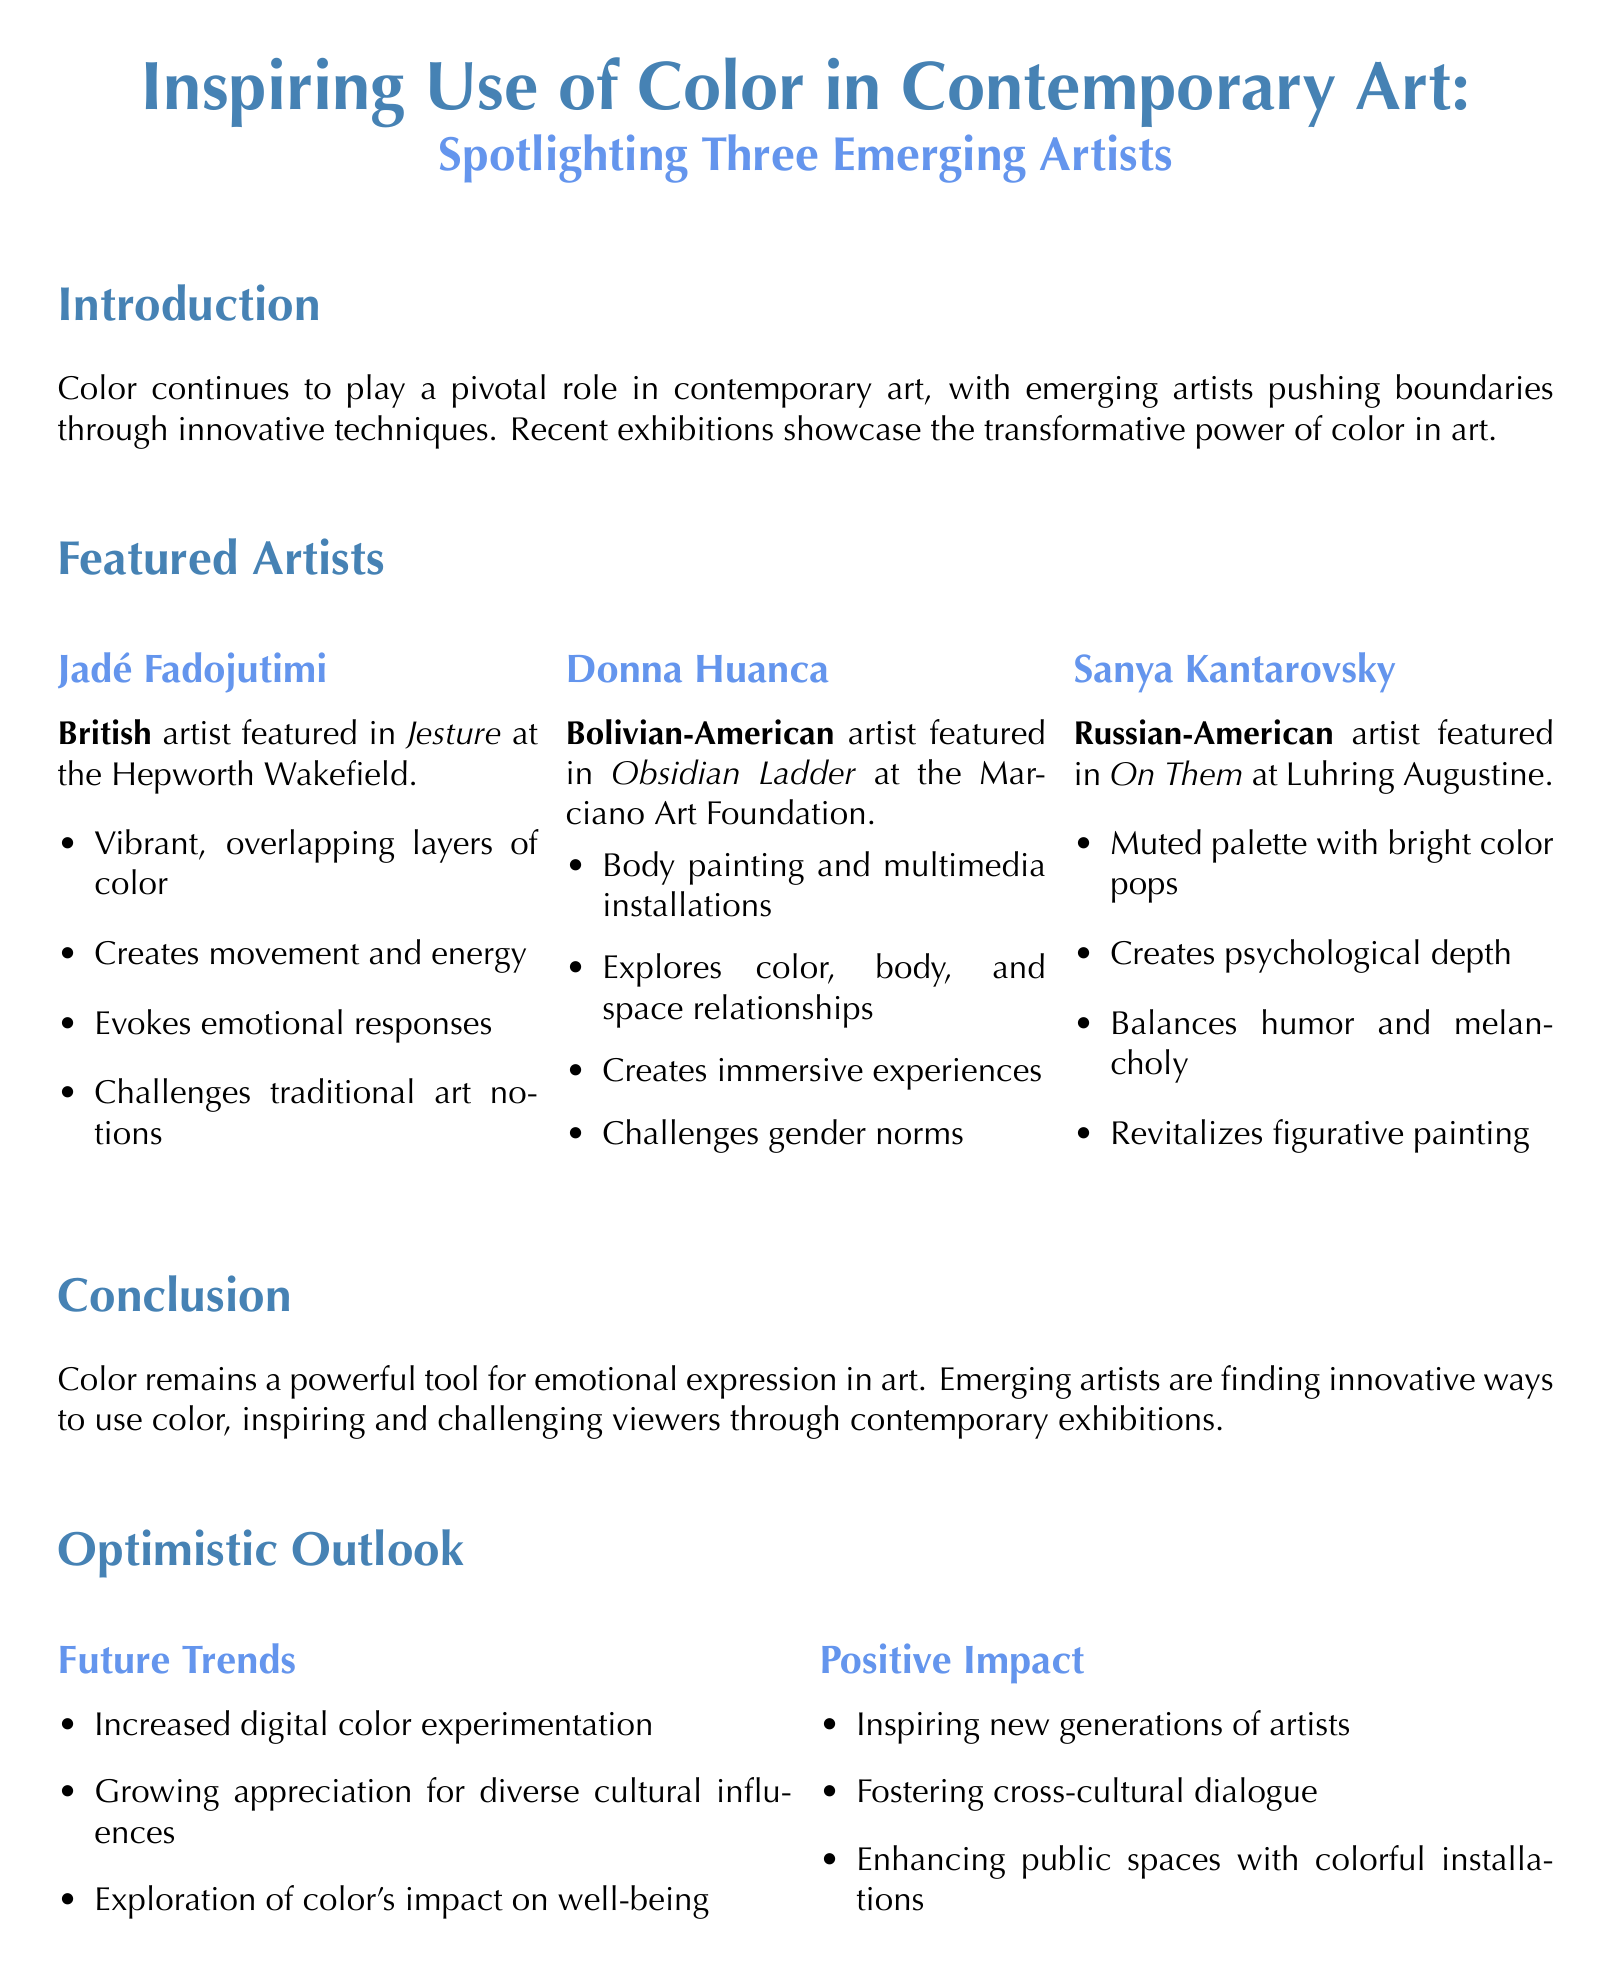What is the title of the memo? The title of the memo is clearly stated at the top of the document.
Answer: Inspiring Use of Color in Contemporary Art: Spotlighting Three Emerging Artists Who is the first artist highlighted in the memo? The memo specifically names the artists in the featured section and their order.
Answer: Jadé Fadojutimi What exhibition features Donna Huanca? The document lists the exhibitions of each artist under their profiles.
Answer: Obsidian Ladder at the Marciano Art Foundation What color technique does Sanya Kantarovsky use? The memo describes the color techniques of each artist in detail.
Answer: Muted palette with strategic pops of bright color What positive aspect is associated with Jadé Fadojutimi's work? For each artist, the memo highlights positive aspects of their artwork, particularly focusing on emotions and creativity.
Answer: Evokes emotional responses through color harmonies What future trend is mentioned in the optimistic outlook? The document lists several future trends related to color use in art that are implied to be optimistic.
Answer: Increased experimentation with digital color technologies Which positive impact is noted for public spaces? The memo summarizes the effects of color in art, including its impact on public spaces.
Answer: Enhancing public spaces and improving quality of life through colorful art installations What nationality is Donna Huanca? The document includes the nationality of each artist, providing quick reference to their background.
Answer: Bolivian-American 